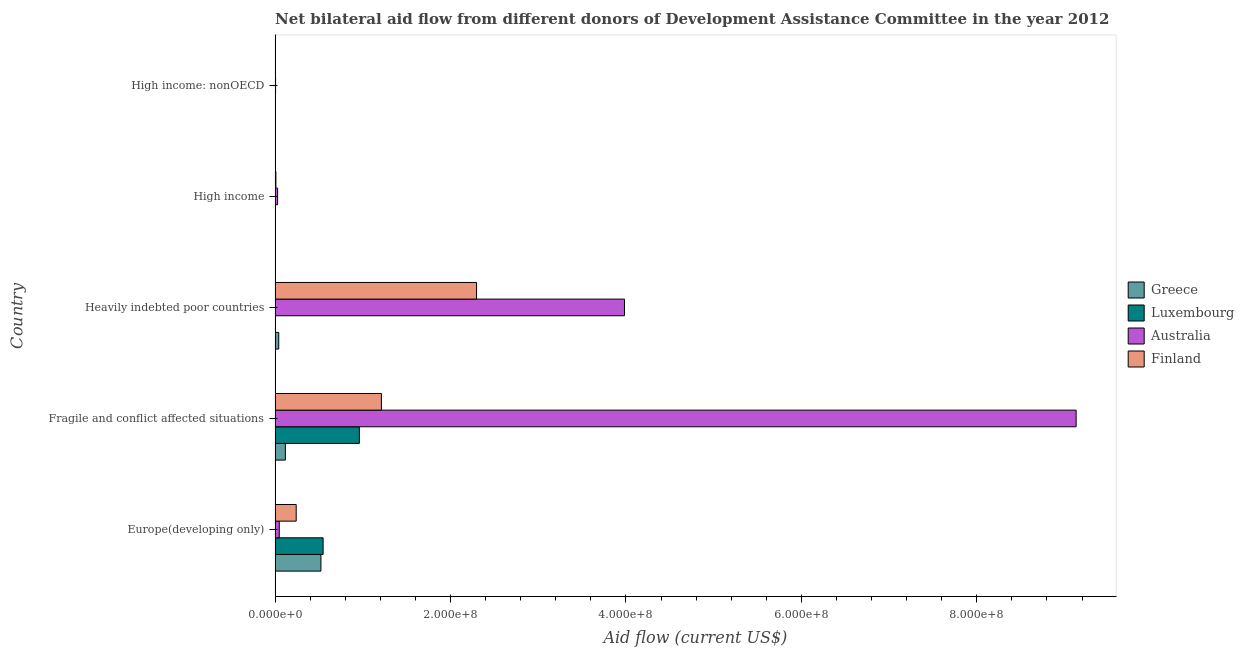Are the number of bars per tick equal to the number of legend labels?
Your answer should be very brief. Yes. How many bars are there on the 5th tick from the top?
Your response must be concise. 4. What is the label of the 1st group of bars from the top?
Offer a very short reply. High income: nonOECD. In how many cases, is the number of bars for a given country not equal to the number of legend labels?
Make the answer very short. 0. What is the amount of aid given by finland in Europe(developing only)?
Ensure brevity in your answer.  2.41e+07. Across all countries, what is the maximum amount of aid given by luxembourg?
Offer a terse response. 9.61e+07. Across all countries, what is the minimum amount of aid given by greece?
Your answer should be very brief. 1.20e+05. In which country was the amount of aid given by finland maximum?
Offer a very short reply. Heavily indebted poor countries. In which country was the amount of aid given by greece minimum?
Your answer should be compact. High income: nonOECD. What is the total amount of aid given by finland in the graph?
Make the answer very short. 3.76e+08. What is the difference between the amount of aid given by australia in Heavily indebted poor countries and that in High income?
Give a very brief answer. 3.95e+08. What is the difference between the amount of aid given by australia in High income and the amount of aid given by greece in Fragile and conflict affected situations?
Provide a succinct answer. -8.84e+06. What is the average amount of aid given by greece per country?
Provide a short and direct response. 1.37e+07. What is the difference between the amount of aid given by australia and amount of aid given by greece in Heavily indebted poor countries?
Offer a terse response. 3.94e+08. What is the ratio of the amount of aid given by luxembourg in Europe(developing only) to that in High income: nonOECD?
Provide a short and direct response. 195.54. What is the difference between the highest and the second highest amount of aid given by finland?
Keep it short and to the point. 1.08e+08. What is the difference between the highest and the lowest amount of aid given by finland?
Ensure brevity in your answer.  2.29e+08. In how many countries, is the amount of aid given by finland greater than the average amount of aid given by finland taken over all countries?
Keep it short and to the point. 2. Is it the case that in every country, the sum of the amount of aid given by luxembourg and amount of aid given by finland is greater than the sum of amount of aid given by australia and amount of aid given by greece?
Your answer should be compact. No. What does the 4th bar from the bottom in High income represents?
Your response must be concise. Finland. How many countries are there in the graph?
Your answer should be very brief. 5. Are the values on the major ticks of X-axis written in scientific E-notation?
Provide a succinct answer. Yes. Does the graph contain grids?
Offer a terse response. No. How many legend labels are there?
Your answer should be very brief. 4. How are the legend labels stacked?
Your answer should be compact. Vertical. What is the title of the graph?
Ensure brevity in your answer.  Net bilateral aid flow from different donors of Development Assistance Committee in the year 2012. What is the label or title of the X-axis?
Offer a very short reply. Aid flow (current US$). What is the label or title of the Y-axis?
Keep it short and to the point. Country. What is the Aid flow (current US$) of Greece in Europe(developing only)?
Your response must be concise. 5.23e+07. What is the Aid flow (current US$) in Luxembourg in Europe(developing only)?
Offer a terse response. 5.48e+07. What is the Aid flow (current US$) in Australia in Europe(developing only)?
Keep it short and to the point. 4.78e+06. What is the Aid flow (current US$) in Finland in Europe(developing only)?
Ensure brevity in your answer.  2.41e+07. What is the Aid flow (current US$) of Greece in Fragile and conflict affected situations?
Your answer should be compact. 1.17e+07. What is the Aid flow (current US$) of Luxembourg in Fragile and conflict affected situations?
Your answer should be very brief. 9.61e+07. What is the Aid flow (current US$) of Australia in Fragile and conflict affected situations?
Offer a very short reply. 9.13e+08. What is the Aid flow (current US$) of Finland in Fragile and conflict affected situations?
Provide a short and direct response. 1.21e+08. What is the Aid flow (current US$) in Greece in Heavily indebted poor countries?
Your answer should be very brief. 4.19e+06. What is the Aid flow (current US$) of Luxembourg in Heavily indebted poor countries?
Your answer should be compact. 3.40e+05. What is the Aid flow (current US$) of Australia in Heavily indebted poor countries?
Give a very brief answer. 3.98e+08. What is the Aid flow (current US$) of Finland in Heavily indebted poor countries?
Your answer should be compact. 2.30e+08. What is the Aid flow (current US$) in Australia in High income?
Offer a very short reply. 2.90e+06. What is the Aid flow (current US$) in Finland in High income?
Your answer should be very brief. 9.20e+05. What is the Aid flow (current US$) in Greece in High income: nonOECD?
Make the answer very short. 1.20e+05. What is the Aid flow (current US$) in Australia in High income: nonOECD?
Ensure brevity in your answer.  5.70e+05. Across all countries, what is the maximum Aid flow (current US$) in Greece?
Make the answer very short. 5.23e+07. Across all countries, what is the maximum Aid flow (current US$) of Luxembourg?
Ensure brevity in your answer.  9.61e+07. Across all countries, what is the maximum Aid flow (current US$) in Australia?
Provide a short and direct response. 9.13e+08. Across all countries, what is the maximum Aid flow (current US$) in Finland?
Your answer should be very brief. 2.30e+08. Across all countries, what is the minimum Aid flow (current US$) in Greece?
Your response must be concise. 1.20e+05. Across all countries, what is the minimum Aid flow (current US$) in Luxembourg?
Provide a succinct answer. 6.00e+04. Across all countries, what is the minimum Aid flow (current US$) of Australia?
Provide a succinct answer. 5.70e+05. Across all countries, what is the minimum Aid flow (current US$) in Finland?
Your response must be concise. 2.80e+05. What is the total Aid flow (current US$) of Greece in the graph?
Your response must be concise. 6.85e+07. What is the total Aid flow (current US$) of Luxembourg in the graph?
Offer a very short reply. 1.52e+08. What is the total Aid flow (current US$) of Australia in the graph?
Keep it short and to the point. 1.32e+09. What is the total Aid flow (current US$) of Finland in the graph?
Provide a short and direct response. 3.76e+08. What is the difference between the Aid flow (current US$) of Greece in Europe(developing only) and that in Fragile and conflict affected situations?
Provide a succinct answer. 4.05e+07. What is the difference between the Aid flow (current US$) in Luxembourg in Europe(developing only) and that in Fragile and conflict affected situations?
Your response must be concise. -4.13e+07. What is the difference between the Aid flow (current US$) of Australia in Europe(developing only) and that in Fragile and conflict affected situations?
Your answer should be compact. -9.08e+08. What is the difference between the Aid flow (current US$) of Finland in Europe(developing only) and that in Fragile and conflict affected situations?
Offer a very short reply. -9.71e+07. What is the difference between the Aid flow (current US$) in Greece in Europe(developing only) and that in Heavily indebted poor countries?
Offer a terse response. 4.81e+07. What is the difference between the Aid flow (current US$) of Luxembourg in Europe(developing only) and that in Heavily indebted poor countries?
Provide a succinct answer. 5.44e+07. What is the difference between the Aid flow (current US$) of Australia in Europe(developing only) and that in Heavily indebted poor countries?
Make the answer very short. -3.94e+08. What is the difference between the Aid flow (current US$) of Finland in Europe(developing only) and that in Heavily indebted poor countries?
Your response must be concise. -2.06e+08. What is the difference between the Aid flow (current US$) of Greece in Europe(developing only) and that in High income?
Offer a very short reply. 5.20e+07. What is the difference between the Aid flow (current US$) of Luxembourg in Europe(developing only) and that in High income?
Ensure brevity in your answer.  5.47e+07. What is the difference between the Aid flow (current US$) in Australia in Europe(developing only) and that in High income?
Keep it short and to the point. 1.88e+06. What is the difference between the Aid flow (current US$) in Finland in Europe(developing only) and that in High income?
Keep it short and to the point. 2.32e+07. What is the difference between the Aid flow (current US$) of Greece in Europe(developing only) and that in High income: nonOECD?
Keep it short and to the point. 5.21e+07. What is the difference between the Aid flow (current US$) in Luxembourg in Europe(developing only) and that in High income: nonOECD?
Make the answer very short. 5.45e+07. What is the difference between the Aid flow (current US$) in Australia in Europe(developing only) and that in High income: nonOECD?
Provide a short and direct response. 4.21e+06. What is the difference between the Aid flow (current US$) of Finland in Europe(developing only) and that in High income: nonOECD?
Give a very brief answer. 2.38e+07. What is the difference between the Aid flow (current US$) in Greece in Fragile and conflict affected situations and that in Heavily indebted poor countries?
Your response must be concise. 7.55e+06. What is the difference between the Aid flow (current US$) in Luxembourg in Fragile and conflict affected situations and that in Heavily indebted poor countries?
Your answer should be compact. 9.57e+07. What is the difference between the Aid flow (current US$) in Australia in Fragile and conflict affected situations and that in Heavily indebted poor countries?
Your answer should be compact. 5.15e+08. What is the difference between the Aid flow (current US$) in Finland in Fragile and conflict affected situations and that in Heavily indebted poor countries?
Keep it short and to the point. -1.08e+08. What is the difference between the Aid flow (current US$) in Greece in Fragile and conflict affected situations and that in High income?
Your response must be concise. 1.15e+07. What is the difference between the Aid flow (current US$) in Luxembourg in Fragile and conflict affected situations and that in High income?
Make the answer very short. 9.60e+07. What is the difference between the Aid flow (current US$) of Australia in Fragile and conflict affected situations and that in High income?
Offer a very short reply. 9.10e+08. What is the difference between the Aid flow (current US$) in Finland in Fragile and conflict affected situations and that in High income?
Provide a short and direct response. 1.20e+08. What is the difference between the Aid flow (current US$) in Greece in Fragile and conflict affected situations and that in High income: nonOECD?
Make the answer very short. 1.16e+07. What is the difference between the Aid flow (current US$) of Luxembourg in Fragile and conflict affected situations and that in High income: nonOECD?
Make the answer very short. 9.58e+07. What is the difference between the Aid flow (current US$) in Australia in Fragile and conflict affected situations and that in High income: nonOECD?
Offer a terse response. 9.13e+08. What is the difference between the Aid flow (current US$) in Finland in Fragile and conflict affected situations and that in High income: nonOECD?
Provide a succinct answer. 1.21e+08. What is the difference between the Aid flow (current US$) of Greece in Heavily indebted poor countries and that in High income?
Make the answer very short. 3.96e+06. What is the difference between the Aid flow (current US$) in Australia in Heavily indebted poor countries and that in High income?
Ensure brevity in your answer.  3.95e+08. What is the difference between the Aid flow (current US$) of Finland in Heavily indebted poor countries and that in High income?
Your answer should be compact. 2.29e+08. What is the difference between the Aid flow (current US$) in Greece in Heavily indebted poor countries and that in High income: nonOECD?
Offer a terse response. 4.07e+06. What is the difference between the Aid flow (current US$) in Luxembourg in Heavily indebted poor countries and that in High income: nonOECD?
Offer a very short reply. 6.00e+04. What is the difference between the Aid flow (current US$) of Australia in Heavily indebted poor countries and that in High income: nonOECD?
Ensure brevity in your answer.  3.98e+08. What is the difference between the Aid flow (current US$) in Finland in Heavily indebted poor countries and that in High income: nonOECD?
Your answer should be very brief. 2.29e+08. What is the difference between the Aid flow (current US$) in Greece in High income and that in High income: nonOECD?
Your response must be concise. 1.10e+05. What is the difference between the Aid flow (current US$) of Australia in High income and that in High income: nonOECD?
Ensure brevity in your answer.  2.33e+06. What is the difference between the Aid flow (current US$) of Finland in High income and that in High income: nonOECD?
Give a very brief answer. 6.40e+05. What is the difference between the Aid flow (current US$) of Greece in Europe(developing only) and the Aid flow (current US$) of Luxembourg in Fragile and conflict affected situations?
Keep it short and to the point. -4.38e+07. What is the difference between the Aid flow (current US$) of Greece in Europe(developing only) and the Aid flow (current US$) of Australia in Fragile and conflict affected situations?
Provide a succinct answer. -8.61e+08. What is the difference between the Aid flow (current US$) in Greece in Europe(developing only) and the Aid flow (current US$) in Finland in Fragile and conflict affected situations?
Keep it short and to the point. -6.90e+07. What is the difference between the Aid flow (current US$) of Luxembourg in Europe(developing only) and the Aid flow (current US$) of Australia in Fragile and conflict affected situations?
Your answer should be compact. -8.58e+08. What is the difference between the Aid flow (current US$) in Luxembourg in Europe(developing only) and the Aid flow (current US$) in Finland in Fragile and conflict affected situations?
Ensure brevity in your answer.  -6.65e+07. What is the difference between the Aid flow (current US$) in Australia in Europe(developing only) and the Aid flow (current US$) in Finland in Fragile and conflict affected situations?
Offer a very short reply. -1.16e+08. What is the difference between the Aid flow (current US$) of Greece in Europe(developing only) and the Aid flow (current US$) of Luxembourg in Heavily indebted poor countries?
Keep it short and to the point. 5.19e+07. What is the difference between the Aid flow (current US$) in Greece in Europe(developing only) and the Aid flow (current US$) in Australia in Heavily indebted poor countries?
Your answer should be compact. -3.46e+08. What is the difference between the Aid flow (current US$) of Greece in Europe(developing only) and the Aid flow (current US$) of Finland in Heavily indebted poor countries?
Your answer should be very brief. -1.77e+08. What is the difference between the Aid flow (current US$) in Luxembourg in Europe(developing only) and the Aid flow (current US$) in Australia in Heavily indebted poor countries?
Offer a very short reply. -3.44e+08. What is the difference between the Aid flow (current US$) in Luxembourg in Europe(developing only) and the Aid flow (current US$) in Finland in Heavily indebted poor countries?
Provide a succinct answer. -1.75e+08. What is the difference between the Aid flow (current US$) in Australia in Europe(developing only) and the Aid flow (current US$) in Finland in Heavily indebted poor countries?
Make the answer very short. -2.25e+08. What is the difference between the Aid flow (current US$) in Greece in Europe(developing only) and the Aid flow (current US$) in Luxembourg in High income?
Your answer should be very brief. 5.22e+07. What is the difference between the Aid flow (current US$) of Greece in Europe(developing only) and the Aid flow (current US$) of Australia in High income?
Offer a terse response. 4.94e+07. What is the difference between the Aid flow (current US$) in Greece in Europe(developing only) and the Aid flow (current US$) in Finland in High income?
Offer a very short reply. 5.13e+07. What is the difference between the Aid flow (current US$) of Luxembourg in Europe(developing only) and the Aid flow (current US$) of Australia in High income?
Give a very brief answer. 5.18e+07. What is the difference between the Aid flow (current US$) of Luxembourg in Europe(developing only) and the Aid flow (current US$) of Finland in High income?
Give a very brief answer. 5.38e+07. What is the difference between the Aid flow (current US$) in Australia in Europe(developing only) and the Aid flow (current US$) in Finland in High income?
Provide a short and direct response. 3.86e+06. What is the difference between the Aid flow (current US$) in Greece in Europe(developing only) and the Aid flow (current US$) in Luxembourg in High income: nonOECD?
Give a very brief answer. 5.20e+07. What is the difference between the Aid flow (current US$) of Greece in Europe(developing only) and the Aid flow (current US$) of Australia in High income: nonOECD?
Your response must be concise. 5.17e+07. What is the difference between the Aid flow (current US$) in Greece in Europe(developing only) and the Aid flow (current US$) in Finland in High income: nonOECD?
Provide a short and direct response. 5.20e+07. What is the difference between the Aid flow (current US$) of Luxembourg in Europe(developing only) and the Aid flow (current US$) of Australia in High income: nonOECD?
Your answer should be compact. 5.42e+07. What is the difference between the Aid flow (current US$) of Luxembourg in Europe(developing only) and the Aid flow (current US$) of Finland in High income: nonOECD?
Provide a succinct answer. 5.45e+07. What is the difference between the Aid flow (current US$) in Australia in Europe(developing only) and the Aid flow (current US$) in Finland in High income: nonOECD?
Your response must be concise. 4.50e+06. What is the difference between the Aid flow (current US$) of Greece in Fragile and conflict affected situations and the Aid flow (current US$) of Luxembourg in Heavily indebted poor countries?
Provide a short and direct response. 1.14e+07. What is the difference between the Aid flow (current US$) in Greece in Fragile and conflict affected situations and the Aid flow (current US$) in Australia in Heavily indebted poor countries?
Your response must be concise. -3.87e+08. What is the difference between the Aid flow (current US$) of Greece in Fragile and conflict affected situations and the Aid flow (current US$) of Finland in Heavily indebted poor countries?
Give a very brief answer. -2.18e+08. What is the difference between the Aid flow (current US$) in Luxembourg in Fragile and conflict affected situations and the Aid flow (current US$) in Australia in Heavily indebted poor countries?
Keep it short and to the point. -3.02e+08. What is the difference between the Aid flow (current US$) of Luxembourg in Fragile and conflict affected situations and the Aid flow (current US$) of Finland in Heavily indebted poor countries?
Your answer should be very brief. -1.34e+08. What is the difference between the Aid flow (current US$) of Australia in Fragile and conflict affected situations and the Aid flow (current US$) of Finland in Heavily indebted poor countries?
Your response must be concise. 6.84e+08. What is the difference between the Aid flow (current US$) of Greece in Fragile and conflict affected situations and the Aid flow (current US$) of Luxembourg in High income?
Keep it short and to the point. 1.17e+07. What is the difference between the Aid flow (current US$) of Greece in Fragile and conflict affected situations and the Aid flow (current US$) of Australia in High income?
Provide a succinct answer. 8.84e+06. What is the difference between the Aid flow (current US$) of Greece in Fragile and conflict affected situations and the Aid flow (current US$) of Finland in High income?
Offer a very short reply. 1.08e+07. What is the difference between the Aid flow (current US$) in Luxembourg in Fragile and conflict affected situations and the Aid flow (current US$) in Australia in High income?
Your answer should be very brief. 9.32e+07. What is the difference between the Aid flow (current US$) of Luxembourg in Fragile and conflict affected situations and the Aid flow (current US$) of Finland in High income?
Keep it short and to the point. 9.52e+07. What is the difference between the Aid flow (current US$) in Australia in Fragile and conflict affected situations and the Aid flow (current US$) in Finland in High income?
Keep it short and to the point. 9.12e+08. What is the difference between the Aid flow (current US$) of Greece in Fragile and conflict affected situations and the Aid flow (current US$) of Luxembourg in High income: nonOECD?
Offer a terse response. 1.15e+07. What is the difference between the Aid flow (current US$) of Greece in Fragile and conflict affected situations and the Aid flow (current US$) of Australia in High income: nonOECD?
Provide a succinct answer. 1.12e+07. What is the difference between the Aid flow (current US$) of Greece in Fragile and conflict affected situations and the Aid flow (current US$) of Finland in High income: nonOECD?
Your response must be concise. 1.15e+07. What is the difference between the Aid flow (current US$) of Luxembourg in Fragile and conflict affected situations and the Aid flow (current US$) of Australia in High income: nonOECD?
Ensure brevity in your answer.  9.55e+07. What is the difference between the Aid flow (current US$) of Luxembourg in Fragile and conflict affected situations and the Aid flow (current US$) of Finland in High income: nonOECD?
Offer a very short reply. 9.58e+07. What is the difference between the Aid flow (current US$) of Australia in Fragile and conflict affected situations and the Aid flow (current US$) of Finland in High income: nonOECD?
Ensure brevity in your answer.  9.13e+08. What is the difference between the Aid flow (current US$) in Greece in Heavily indebted poor countries and the Aid flow (current US$) in Luxembourg in High income?
Ensure brevity in your answer.  4.13e+06. What is the difference between the Aid flow (current US$) of Greece in Heavily indebted poor countries and the Aid flow (current US$) of Australia in High income?
Your answer should be compact. 1.29e+06. What is the difference between the Aid flow (current US$) in Greece in Heavily indebted poor countries and the Aid flow (current US$) in Finland in High income?
Offer a terse response. 3.27e+06. What is the difference between the Aid flow (current US$) in Luxembourg in Heavily indebted poor countries and the Aid flow (current US$) in Australia in High income?
Your response must be concise. -2.56e+06. What is the difference between the Aid flow (current US$) in Luxembourg in Heavily indebted poor countries and the Aid flow (current US$) in Finland in High income?
Your answer should be very brief. -5.80e+05. What is the difference between the Aid flow (current US$) of Australia in Heavily indebted poor countries and the Aid flow (current US$) of Finland in High income?
Provide a succinct answer. 3.97e+08. What is the difference between the Aid flow (current US$) of Greece in Heavily indebted poor countries and the Aid flow (current US$) of Luxembourg in High income: nonOECD?
Provide a short and direct response. 3.91e+06. What is the difference between the Aid flow (current US$) of Greece in Heavily indebted poor countries and the Aid flow (current US$) of Australia in High income: nonOECD?
Your answer should be very brief. 3.62e+06. What is the difference between the Aid flow (current US$) in Greece in Heavily indebted poor countries and the Aid flow (current US$) in Finland in High income: nonOECD?
Make the answer very short. 3.91e+06. What is the difference between the Aid flow (current US$) of Luxembourg in Heavily indebted poor countries and the Aid flow (current US$) of Australia in High income: nonOECD?
Ensure brevity in your answer.  -2.30e+05. What is the difference between the Aid flow (current US$) in Luxembourg in Heavily indebted poor countries and the Aid flow (current US$) in Finland in High income: nonOECD?
Ensure brevity in your answer.  6.00e+04. What is the difference between the Aid flow (current US$) in Australia in Heavily indebted poor countries and the Aid flow (current US$) in Finland in High income: nonOECD?
Your answer should be compact. 3.98e+08. What is the difference between the Aid flow (current US$) of Greece in High income and the Aid flow (current US$) of Luxembourg in High income: nonOECD?
Ensure brevity in your answer.  -5.00e+04. What is the difference between the Aid flow (current US$) of Greece in High income and the Aid flow (current US$) of Australia in High income: nonOECD?
Keep it short and to the point. -3.40e+05. What is the difference between the Aid flow (current US$) of Luxembourg in High income and the Aid flow (current US$) of Australia in High income: nonOECD?
Give a very brief answer. -5.10e+05. What is the difference between the Aid flow (current US$) of Luxembourg in High income and the Aid flow (current US$) of Finland in High income: nonOECD?
Offer a terse response. -2.20e+05. What is the difference between the Aid flow (current US$) in Australia in High income and the Aid flow (current US$) in Finland in High income: nonOECD?
Offer a very short reply. 2.62e+06. What is the average Aid flow (current US$) of Greece per country?
Your answer should be very brief. 1.37e+07. What is the average Aid flow (current US$) of Luxembourg per country?
Keep it short and to the point. 3.03e+07. What is the average Aid flow (current US$) in Australia per country?
Your response must be concise. 2.64e+08. What is the average Aid flow (current US$) in Finland per country?
Provide a short and direct response. 7.52e+07. What is the difference between the Aid flow (current US$) in Greece and Aid flow (current US$) in Luxembourg in Europe(developing only)?
Keep it short and to the point. -2.49e+06. What is the difference between the Aid flow (current US$) in Greece and Aid flow (current US$) in Australia in Europe(developing only)?
Provide a short and direct response. 4.75e+07. What is the difference between the Aid flow (current US$) in Greece and Aid flow (current US$) in Finland in Europe(developing only)?
Offer a terse response. 2.82e+07. What is the difference between the Aid flow (current US$) in Luxembourg and Aid flow (current US$) in Australia in Europe(developing only)?
Provide a short and direct response. 5.00e+07. What is the difference between the Aid flow (current US$) of Luxembourg and Aid flow (current US$) of Finland in Europe(developing only)?
Provide a succinct answer. 3.07e+07. What is the difference between the Aid flow (current US$) in Australia and Aid flow (current US$) in Finland in Europe(developing only)?
Make the answer very short. -1.93e+07. What is the difference between the Aid flow (current US$) in Greece and Aid flow (current US$) in Luxembourg in Fragile and conflict affected situations?
Provide a short and direct response. -8.43e+07. What is the difference between the Aid flow (current US$) of Greece and Aid flow (current US$) of Australia in Fragile and conflict affected situations?
Offer a very short reply. -9.02e+08. What is the difference between the Aid flow (current US$) of Greece and Aid flow (current US$) of Finland in Fragile and conflict affected situations?
Offer a terse response. -1.09e+08. What is the difference between the Aid flow (current US$) in Luxembourg and Aid flow (current US$) in Australia in Fragile and conflict affected situations?
Provide a succinct answer. -8.17e+08. What is the difference between the Aid flow (current US$) in Luxembourg and Aid flow (current US$) in Finland in Fragile and conflict affected situations?
Offer a very short reply. -2.51e+07. What is the difference between the Aid flow (current US$) in Australia and Aid flow (current US$) in Finland in Fragile and conflict affected situations?
Your answer should be compact. 7.92e+08. What is the difference between the Aid flow (current US$) in Greece and Aid flow (current US$) in Luxembourg in Heavily indebted poor countries?
Ensure brevity in your answer.  3.85e+06. What is the difference between the Aid flow (current US$) in Greece and Aid flow (current US$) in Australia in Heavily indebted poor countries?
Provide a short and direct response. -3.94e+08. What is the difference between the Aid flow (current US$) in Greece and Aid flow (current US$) in Finland in Heavily indebted poor countries?
Offer a very short reply. -2.26e+08. What is the difference between the Aid flow (current US$) of Luxembourg and Aid flow (current US$) of Australia in Heavily indebted poor countries?
Keep it short and to the point. -3.98e+08. What is the difference between the Aid flow (current US$) in Luxembourg and Aid flow (current US$) in Finland in Heavily indebted poor countries?
Offer a very short reply. -2.29e+08. What is the difference between the Aid flow (current US$) in Australia and Aid flow (current US$) in Finland in Heavily indebted poor countries?
Keep it short and to the point. 1.69e+08. What is the difference between the Aid flow (current US$) of Greece and Aid flow (current US$) of Luxembourg in High income?
Provide a short and direct response. 1.70e+05. What is the difference between the Aid flow (current US$) of Greece and Aid flow (current US$) of Australia in High income?
Your answer should be very brief. -2.67e+06. What is the difference between the Aid flow (current US$) of Greece and Aid flow (current US$) of Finland in High income?
Give a very brief answer. -6.90e+05. What is the difference between the Aid flow (current US$) in Luxembourg and Aid flow (current US$) in Australia in High income?
Provide a succinct answer. -2.84e+06. What is the difference between the Aid flow (current US$) in Luxembourg and Aid flow (current US$) in Finland in High income?
Ensure brevity in your answer.  -8.60e+05. What is the difference between the Aid flow (current US$) in Australia and Aid flow (current US$) in Finland in High income?
Make the answer very short. 1.98e+06. What is the difference between the Aid flow (current US$) in Greece and Aid flow (current US$) in Australia in High income: nonOECD?
Provide a short and direct response. -4.50e+05. What is the difference between the Aid flow (current US$) of Greece and Aid flow (current US$) of Finland in High income: nonOECD?
Offer a very short reply. -1.60e+05. What is the difference between the Aid flow (current US$) of Luxembourg and Aid flow (current US$) of Finland in High income: nonOECD?
Your answer should be compact. 0. What is the difference between the Aid flow (current US$) in Australia and Aid flow (current US$) in Finland in High income: nonOECD?
Your answer should be compact. 2.90e+05. What is the ratio of the Aid flow (current US$) in Greece in Europe(developing only) to that in Fragile and conflict affected situations?
Your answer should be compact. 4.45. What is the ratio of the Aid flow (current US$) in Luxembourg in Europe(developing only) to that in Fragile and conflict affected situations?
Offer a terse response. 0.57. What is the ratio of the Aid flow (current US$) of Australia in Europe(developing only) to that in Fragile and conflict affected situations?
Your response must be concise. 0.01. What is the ratio of the Aid flow (current US$) in Finland in Europe(developing only) to that in Fragile and conflict affected situations?
Your answer should be very brief. 0.2. What is the ratio of the Aid flow (current US$) of Greece in Europe(developing only) to that in Heavily indebted poor countries?
Your response must be concise. 12.47. What is the ratio of the Aid flow (current US$) of Luxembourg in Europe(developing only) to that in Heavily indebted poor countries?
Provide a short and direct response. 161.03. What is the ratio of the Aid flow (current US$) of Australia in Europe(developing only) to that in Heavily indebted poor countries?
Ensure brevity in your answer.  0.01. What is the ratio of the Aid flow (current US$) of Finland in Europe(developing only) to that in Heavily indebted poor countries?
Provide a succinct answer. 0.1. What is the ratio of the Aid flow (current US$) of Greece in Europe(developing only) to that in High income?
Make the answer very short. 227.22. What is the ratio of the Aid flow (current US$) in Luxembourg in Europe(developing only) to that in High income?
Your answer should be very brief. 912.5. What is the ratio of the Aid flow (current US$) of Australia in Europe(developing only) to that in High income?
Offer a very short reply. 1.65. What is the ratio of the Aid flow (current US$) of Finland in Europe(developing only) to that in High income?
Offer a terse response. 26.18. What is the ratio of the Aid flow (current US$) of Greece in Europe(developing only) to that in High income: nonOECD?
Give a very brief answer. 435.5. What is the ratio of the Aid flow (current US$) in Luxembourg in Europe(developing only) to that in High income: nonOECD?
Offer a terse response. 195.54. What is the ratio of the Aid flow (current US$) of Australia in Europe(developing only) to that in High income: nonOECD?
Ensure brevity in your answer.  8.39. What is the ratio of the Aid flow (current US$) of Finland in Europe(developing only) to that in High income: nonOECD?
Give a very brief answer. 86.04. What is the ratio of the Aid flow (current US$) in Greece in Fragile and conflict affected situations to that in Heavily indebted poor countries?
Keep it short and to the point. 2.8. What is the ratio of the Aid flow (current US$) of Luxembourg in Fragile and conflict affected situations to that in Heavily indebted poor countries?
Give a very brief answer. 282.59. What is the ratio of the Aid flow (current US$) of Australia in Fragile and conflict affected situations to that in Heavily indebted poor countries?
Provide a succinct answer. 2.29. What is the ratio of the Aid flow (current US$) of Finland in Fragile and conflict affected situations to that in Heavily indebted poor countries?
Your answer should be compact. 0.53. What is the ratio of the Aid flow (current US$) of Greece in Fragile and conflict affected situations to that in High income?
Your answer should be compact. 51.04. What is the ratio of the Aid flow (current US$) of Luxembourg in Fragile and conflict affected situations to that in High income?
Provide a succinct answer. 1601.33. What is the ratio of the Aid flow (current US$) of Australia in Fragile and conflict affected situations to that in High income?
Keep it short and to the point. 314.91. What is the ratio of the Aid flow (current US$) in Finland in Fragile and conflict affected situations to that in High income?
Give a very brief answer. 131.75. What is the ratio of the Aid flow (current US$) of Greece in Fragile and conflict affected situations to that in High income: nonOECD?
Provide a succinct answer. 97.83. What is the ratio of the Aid flow (current US$) of Luxembourg in Fragile and conflict affected situations to that in High income: nonOECD?
Keep it short and to the point. 343.14. What is the ratio of the Aid flow (current US$) of Australia in Fragile and conflict affected situations to that in High income: nonOECD?
Give a very brief answer. 1602.18. What is the ratio of the Aid flow (current US$) in Finland in Fragile and conflict affected situations to that in High income: nonOECD?
Your response must be concise. 432.89. What is the ratio of the Aid flow (current US$) in Greece in Heavily indebted poor countries to that in High income?
Make the answer very short. 18.22. What is the ratio of the Aid flow (current US$) of Luxembourg in Heavily indebted poor countries to that in High income?
Give a very brief answer. 5.67. What is the ratio of the Aid flow (current US$) in Australia in Heavily indebted poor countries to that in High income?
Ensure brevity in your answer.  137.36. What is the ratio of the Aid flow (current US$) of Finland in Heavily indebted poor countries to that in High income?
Give a very brief answer. 249.67. What is the ratio of the Aid flow (current US$) in Greece in Heavily indebted poor countries to that in High income: nonOECD?
Your answer should be very brief. 34.92. What is the ratio of the Aid flow (current US$) of Luxembourg in Heavily indebted poor countries to that in High income: nonOECD?
Give a very brief answer. 1.21. What is the ratio of the Aid flow (current US$) of Australia in Heavily indebted poor countries to that in High income: nonOECD?
Make the answer very short. 698.84. What is the ratio of the Aid flow (current US$) of Finland in Heavily indebted poor countries to that in High income: nonOECD?
Ensure brevity in your answer.  820.36. What is the ratio of the Aid flow (current US$) in Greece in High income to that in High income: nonOECD?
Your answer should be compact. 1.92. What is the ratio of the Aid flow (current US$) in Luxembourg in High income to that in High income: nonOECD?
Your answer should be very brief. 0.21. What is the ratio of the Aid flow (current US$) in Australia in High income to that in High income: nonOECD?
Keep it short and to the point. 5.09. What is the ratio of the Aid flow (current US$) of Finland in High income to that in High income: nonOECD?
Give a very brief answer. 3.29. What is the difference between the highest and the second highest Aid flow (current US$) in Greece?
Keep it short and to the point. 4.05e+07. What is the difference between the highest and the second highest Aid flow (current US$) of Luxembourg?
Your answer should be very brief. 4.13e+07. What is the difference between the highest and the second highest Aid flow (current US$) of Australia?
Keep it short and to the point. 5.15e+08. What is the difference between the highest and the second highest Aid flow (current US$) of Finland?
Keep it short and to the point. 1.08e+08. What is the difference between the highest and the lowest Aid flow (current US$) of Greece?
Ensure brevity in your answer.  5.21e+07. What is the difference between the highest and the lowest Aid flow (current US$) in Luxembourg?
Your response must be concise. 9.60e+07. What is the difference between the highest and the lowest Aid flow (current US$) in Australia?
Provide a short and direct response. 9.13e+08. What is the difference between the highest and the lowest Aid flow (current US$) in Finland?
Offer a very short reply. 2.29e+08. 